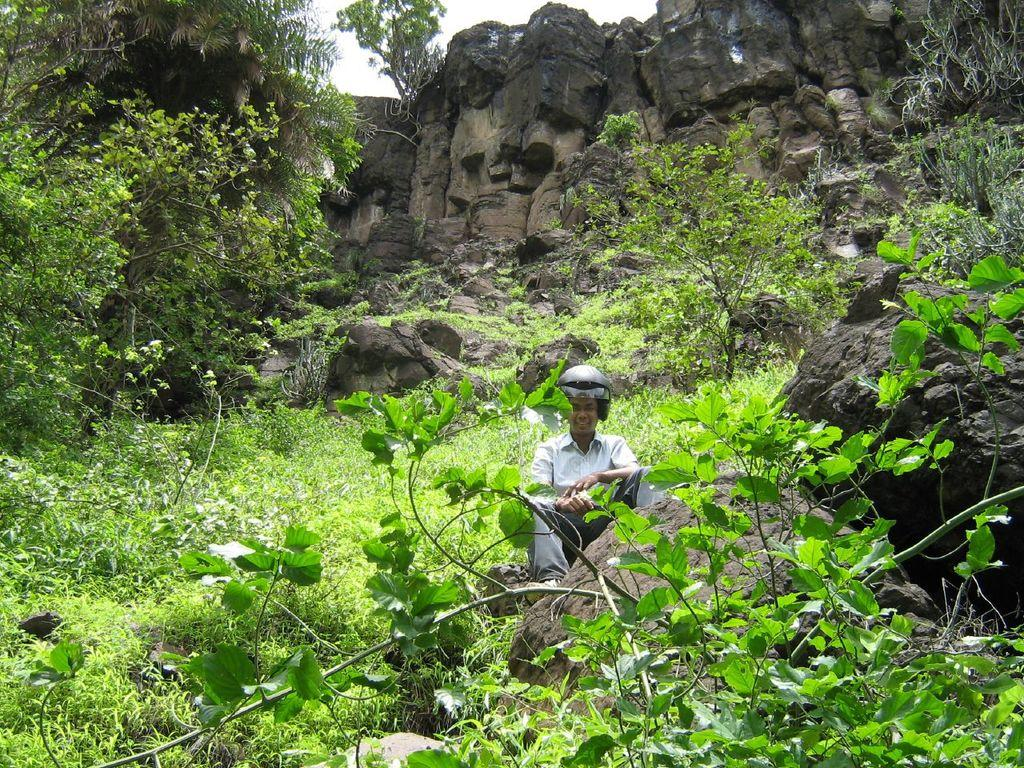What is the man in the image doing? The man is sitting in the image. What is the man wearing on his head? The man is wearing a helmet. What type of vegetation can be seen in the image? There are plants, grass, and trees in the image. What other natural elements are present in the image? There are rocks in the image. What can be seen in the background of the image? The sky is visible in the background of the image. What type of cakes can be seen in the image? There are no cakes present in the image. What is the man using to stir the pot in the image? There is no pot or stirring stick present in the image. 